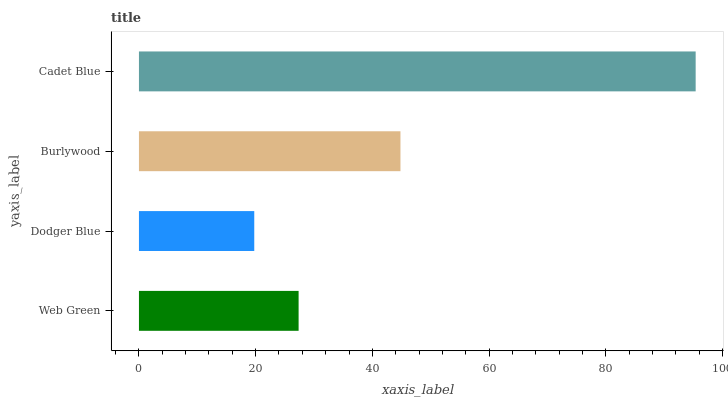Is Dodger Blue the minimum?
Answer yes or no. Yes. Is Cadet Blue the maximum?
Answer yes or no. Yes. Is Burlywood the minimum?
Answer yes or no. No. Is Burlywood the maximum?
Answer yes or no. No. Is Burlywood greater than Dodger Blue?
Answer yes or no. Yes. Is Dodger Blue less than Burlywood?
Answer yes or no. Yes. Is Dodger Blue greater than Burlywood?
Answer yes or no. No. Is Burlywood less than Dodger Blue?
Answer yes or no. No. Is Burlywood the high median?
Answer yes or no. Yes. Is Web Green the low median?
Answer yes or no. Yes. Is Web Green the high median?
Answer yes or no. No. Is Dodger Blue the low median?
Answer yes or no. No. 